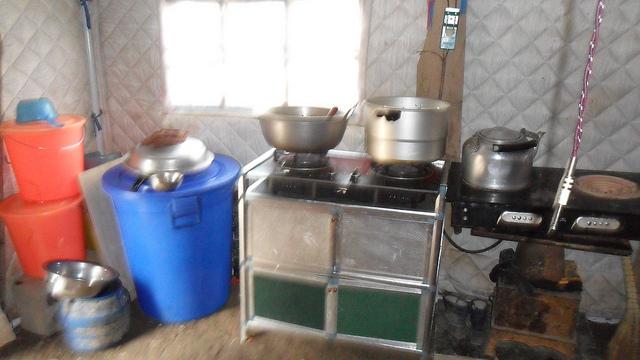What room is pictured in this scene?
Answer briefly. Kitchen. What color is the countertop?
Write a very short answer. Black. Would the blue bucket contain the contents from both orange buckets?
Answer briefly. Yes. Is there a plant present?
Give a very brief answer. No. Was this scene displayed during the day?
Give a very brief answer. Yes. Do people cook here?
Write a very short answer. Yes. 